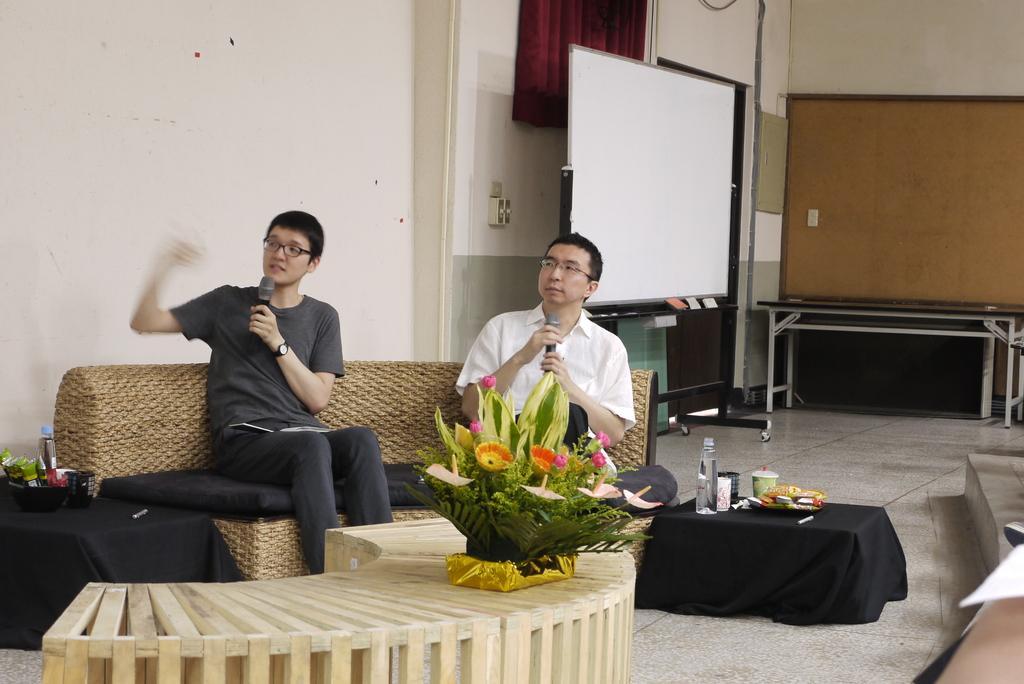Describe this image in one or two sentences. This picture shows two men seated and speaking with the help of a microphone and we see flower vase and a water bottle on the table and a whiteboard 